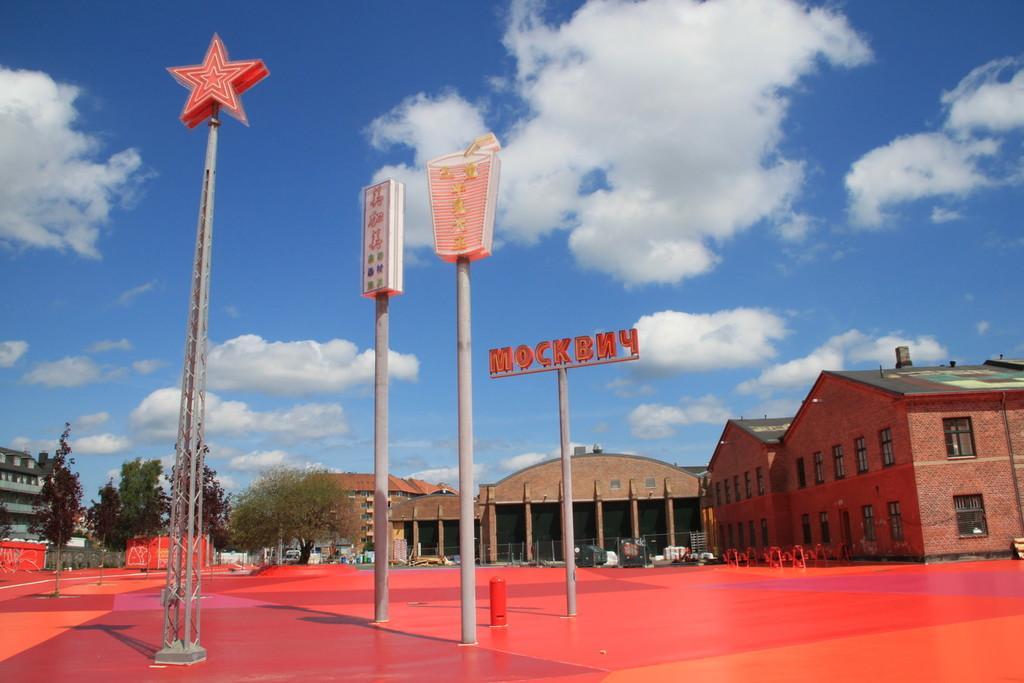Can you describe this image briefly? In this image there are poles and boards. There are buildings and trees. In the background there is sky and we can see some objects. 